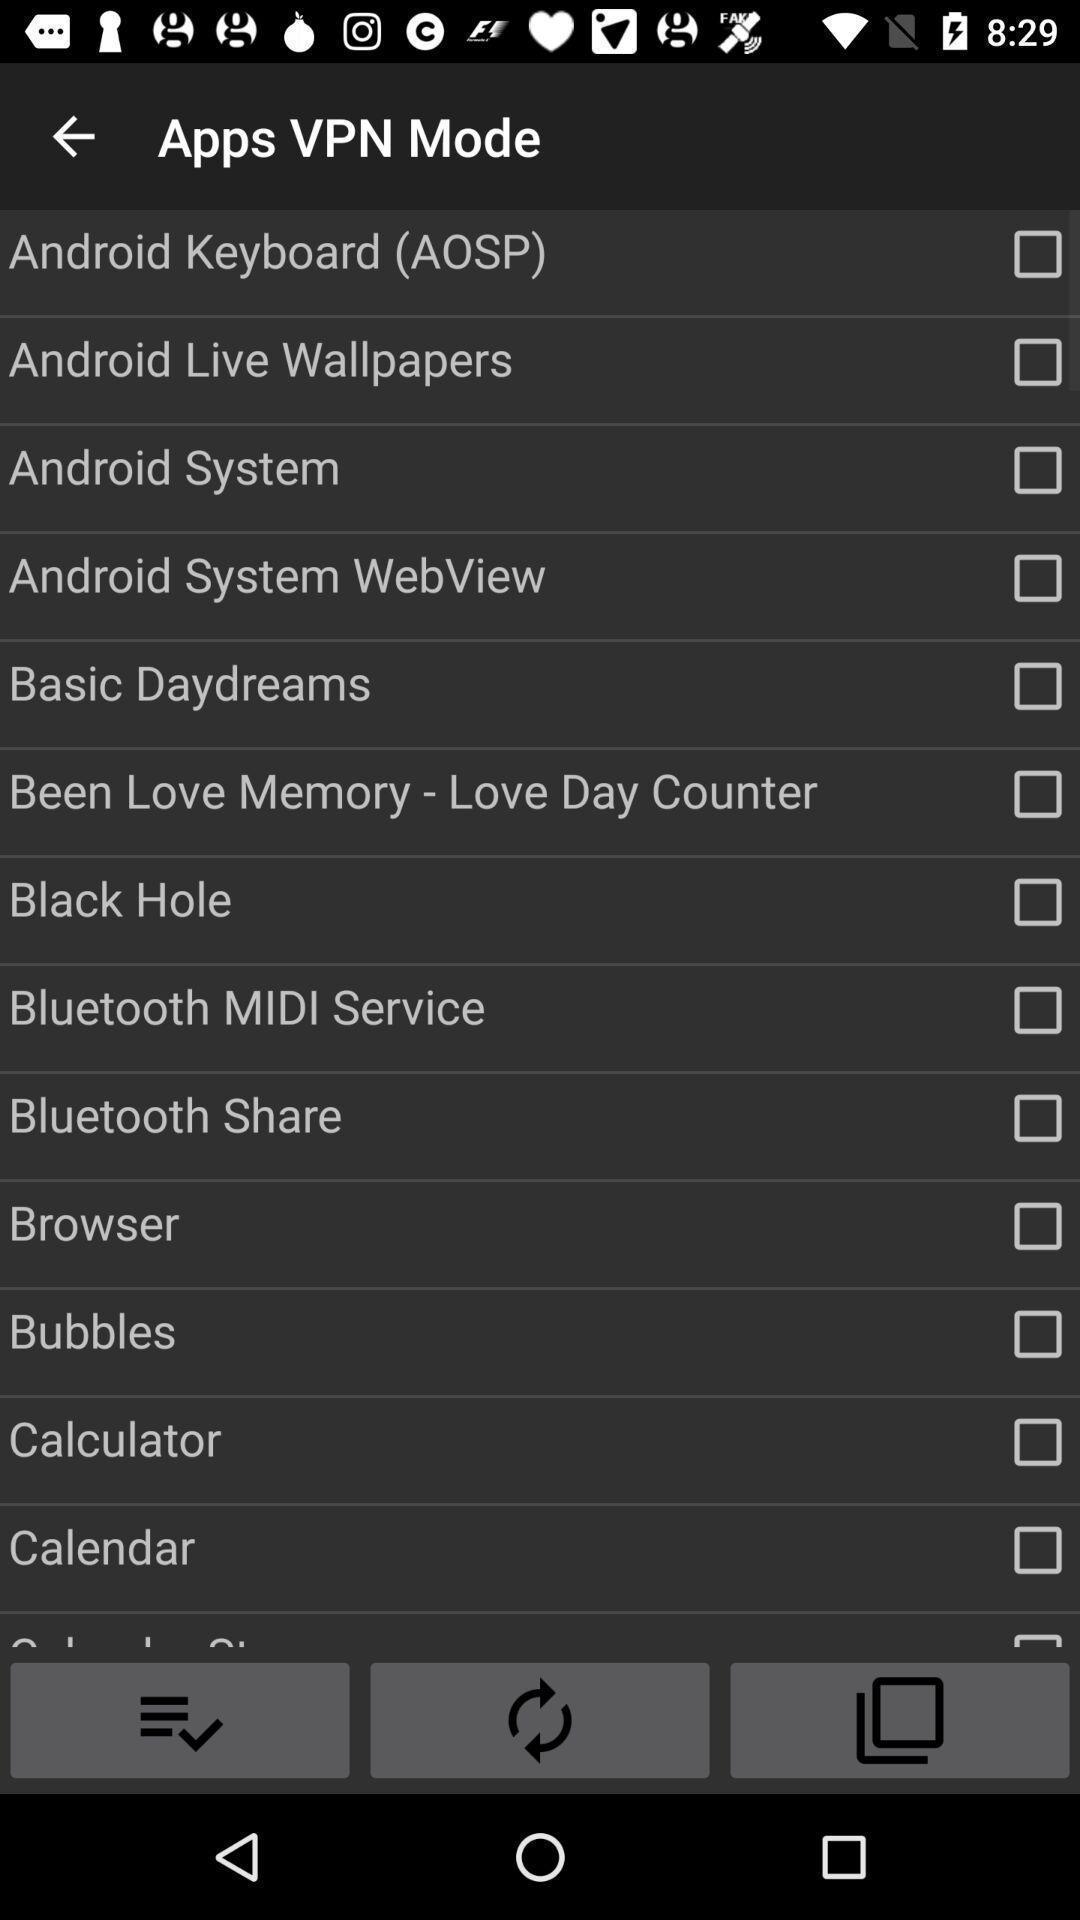What can you discern from this picture? Page displaying options in the phone. 